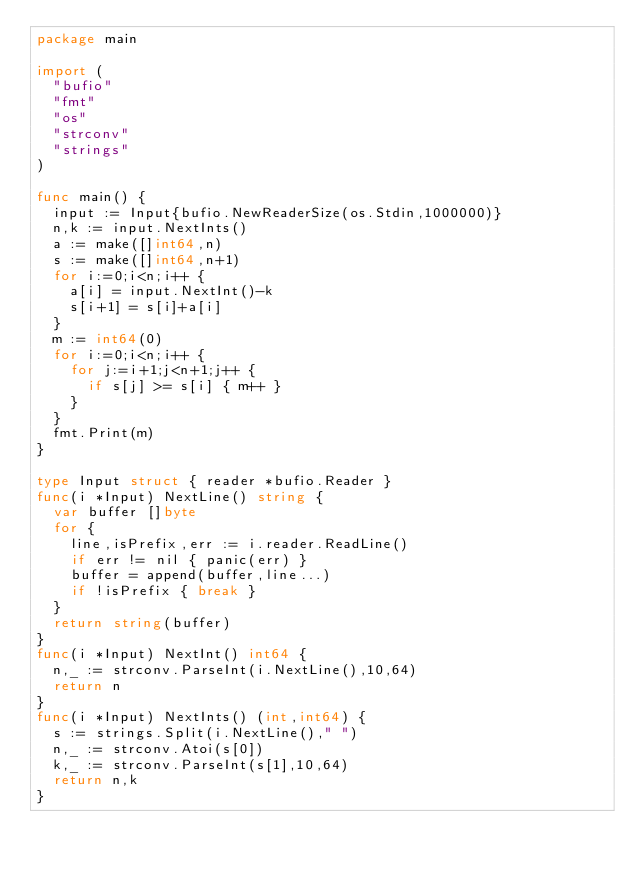Convert code to text. <code><loc_0><loc_0><loc_500><loc_500><_Go_>package main

import (
  "bufio"
  "fmt"
  "os"
  "strconv"
  "strings"
)

func main() {
  input := Input{bufio.NewReaderSize(os.Stdin,1000000)}
  n,k := input.NextInts()
  a := make([]int64,n)
  s := make([]int64,n+1)
  for i:=0;i<n;i++ {
    a[i] = input.NextInt()-k
    s[i+1] = s[i]+a[i]
  }
  m := int64(0)
  for i:=0;i<n;i++ {
    for j:=i+1;j<n+1;j++ {
      if s[j] >= s[i] { m++ }
    }
  }
  fmt.Print(m)
}

type Input struct { reader *bufio.Reader }
func(i *Input) NextLine() string {
  var buffer []byte
  for {
    line,isPrefix,err := i.reader.ReadLine()
    if err != nil { panic(err) }
    buffer = append(buffer,line...)
    if !isPrefix { break }
  }
  return string(buffer)
}
func(i *Input) NextInt() int64 {
  n,_ := strconv.ParseInt(i.NextLine(),10,64)
  return n
}
func(i *Input) NextInts() (int,int64) {
  s := strings.Split(i.NextLine()," ")
  n,_ := strconv.Atoi(s[0])
  k,_ := strconv.ParseInt(s[1],10,64)
  return n,k
}</code> 